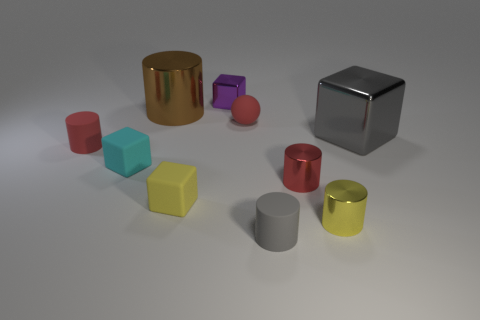Subtract all large cylinders. How many cylinders are left? 4 Subtract all yellow cylinders. How many cylinders are left? 4 Subtract all blue cylinders. Subtract all purple balls. How many cylinders are left? 5 Subtract all cubes. How many objects are left? 6 Add 1 gray matte things. How many gray matte things exist? 2 Subtract 0 cyan cylinders. How many objects are left? 10 Subtract all cubes. Subtract all large matte things. How many objects are left? 6 Add 8 small matte cylinders. How many small matte cylinders are left? 10 